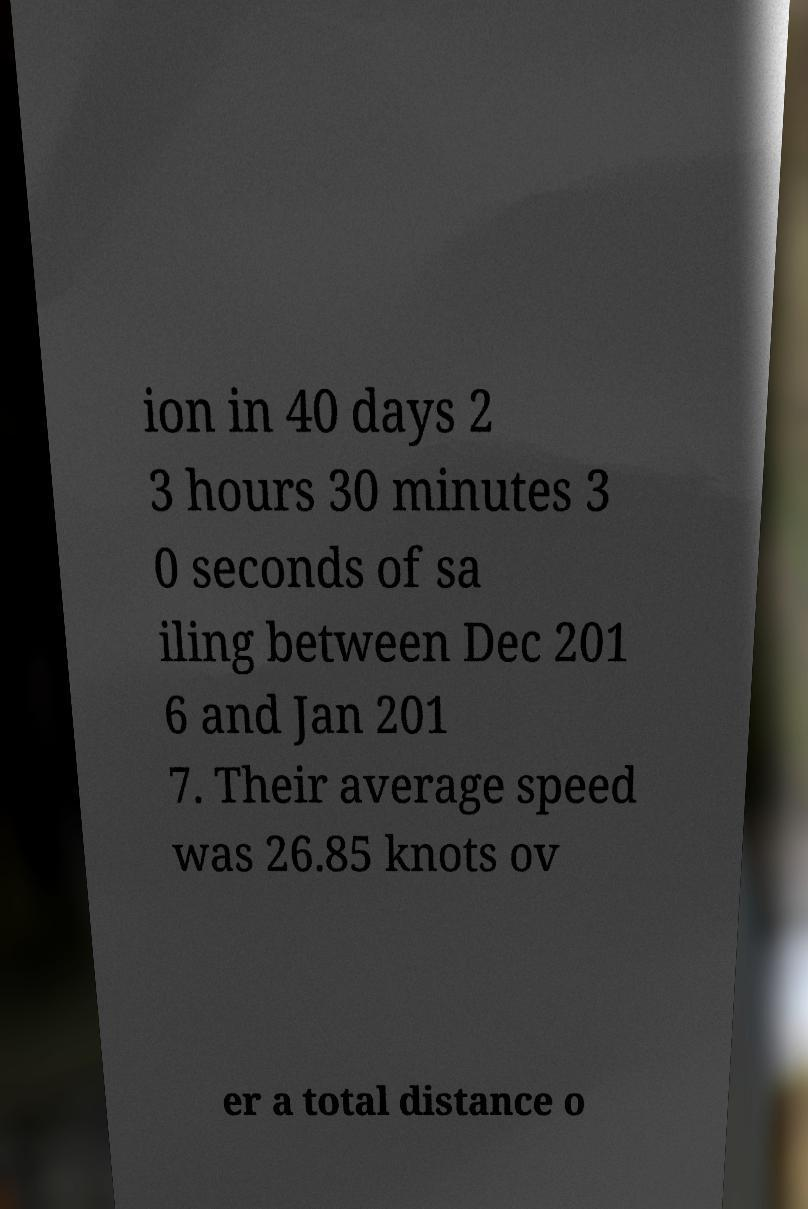Can you read and provide the text displayed in the image?This photo seems to have some interesting text. Can you extract and type it out for me? ion in 40 days 2 3 hours 30 minutes 3 0 seconds of sa iling between Dec 201 6 and Jan 201 7. Their average speed was 26.85 knots ov er a total distance o 